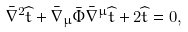Convert formula to latex. <formula><loc_0><loc_0><loc_500><loc_500>\bar { \nabla } ^ { 2 } \widehat { t } + \bar { \nabla } _ { \mu } \bar { \Phi } \bar { \nabla } ^ { \mu } \widehat { t } + 2 \widehat { t } = 0 ,</formula> 